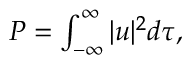<formula> <loc_0><loc_0><loc_500><loc_500>\begin{array} { r } { P = \int _ { - \infty } ^ { \infty } | u | ^ { 2 } d \tau , } \end{array}</formula> 